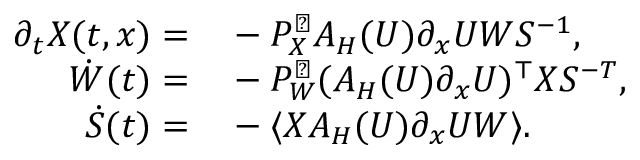<formula> <loc_0><loc_0><loc_500><loc_500>\begin{array} { r l } { \partial _ { t } X ( t , x ) = } & - P _ { X } ^ { \perp } A _ { H } ( U ) \partial _ { x } U W S ^ { - 1 } , } \\ { \dot { W } ( t ) = } & - P _ { W } ^ { \perp } ( A _ { H } ( U ) \partial _ { x } U ) ^ { \top } X S ^ { - T } , } \\ { \dot { S } ( t ) = } & - \langle X A _ { H } ( U ) \partial _ { x } U W \rangle . } \end{array}</formula> 